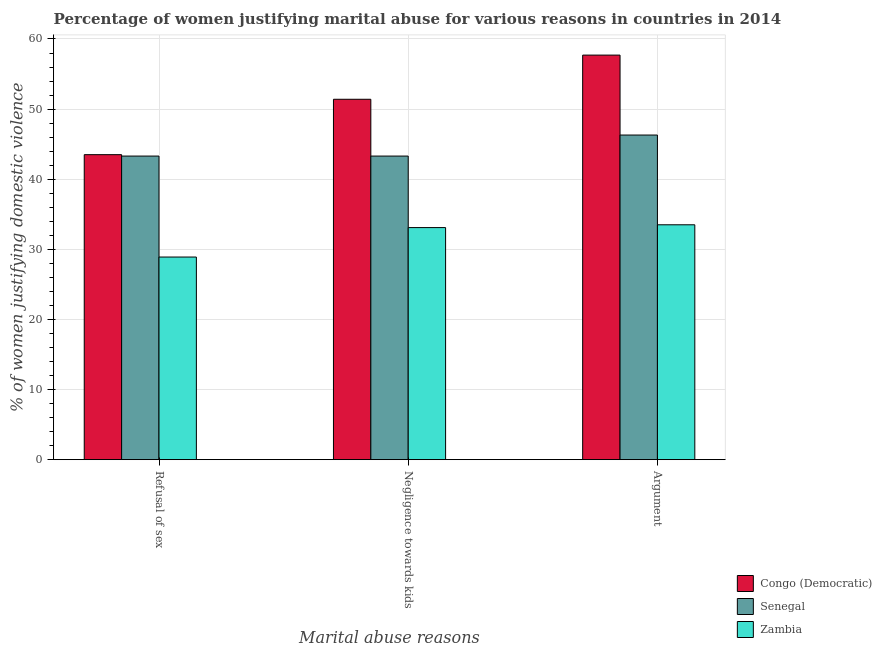How many bars are there on the 2nd tick from the left?
Keep it short and to the point. 3. How many bars are there on the 1st tick from the right?
Keep it short and to the point. 3. What is the label of the 2nd group of bars from the left?
Your answer should be compact. Negligence towards kids. What is the percentage of women justifying domestic violence due to arguments in Zambia?
Offer a terse response. 33.5. Across all countries, what is the maximum percentage of women justifying domestic violence due to arguments?
Keep it short and to the point. 57.7. Across all countries, what is the minimum percentage of women justifying domestic violence due to arguments?
Offer a terse response. 33.5. In which country was the percentage of women justifying domestic violence due to arguments maximum?
Your answer should be very brief. Congo (Democratic). In which country was the percentage of women justifying domestic violence due to negligence towards kids minimum?
Give a very brief answer. Zambia. What is the total percentage of women justifying domestic violence due to refusal of sex in the graph?
Your response must be concise. 115.7. What is the difference between the percentage of women justifying domestic violence due to refusal of sex in Senegal and that in Zambia?
Keep it short and to the point. 14.4. What is the difference between the percentage of women justifying domestic violence due to arguments in Senegal and the percentage of women justifying domestic violence due to negligence towards kids in Zambia?
Your answer should be very brief. 13.2. What is the average percentage of women justifying domestic violence due to negligence towards kids per country?
Make the answer very short. 42.6. In how many countries, is the percentage of women justifying domestic violence due to arguments greater than 20 %?
Your answer should be very brief. 3. What is the ratio of the percentage of women justifying domestic violence due to refusal of sex in Congo (Democratic) to that in Senegal?
Your response must be concise. 1. Is the percentage of women justifying domestic violence due to negligence towards kids in Congo (Democratic) less than that in Zambia?
Ensure brevity in your answer.  No. Is the difference between the percentage of women justifying domestic violence due to arguments in Zambia and Senegal greater than the difference between the percentage of women justifying domestic violence due to negligence towards kids in Zambia and Senegal?
Keep it short and to the point. No. What is the difference between the highest and the second highest percentage of women justifying domestic violence due to negligence towards kids?
Make the answer very short. 8.1. What is the difference between the highest and the lowest percentage of women justifying domestic violence due to refusal of sex?
Ensure brevity in your answer.  14.6. Is the sum of the percentage of women justifying domestic violence due to negligence towards kids in Zambia and Congo (Democratic) greater than the maximum percentage of women justifying domestic violence due to refusal of sex across all countries?
Your response must be concise. Yes. What does the 1st bar from the left in Argument represents?
Keep it short and to the point. Congo (Democratic). What does the 2nd bar from the right in Negligence towards kids represents?
Your response must be concise. Senegal. Is it the case that in every country, the sum of the percentage of women justifying domestic violence due to refusal of sex and percentage of women justifying domestic violence due to negligence towards kids is greater than the percentage of women justifying domestic violence due to arguments?
Ensure brevity in your answer.  Yes. Are all the bars in the graph horizontal?
Give a very brief answer. No. What is the difference between two consecutive major ticks on the Y-axis?
Offer a terse response. 10. Where does the legend appear in the graph?
Give a very brief answer. Bottom right. What is the title of the graph?
Your answer should be very brief. Percentage of women justifying marital abuse for various reasons in countries in 2014. Does "Tunisia" appear as one of the legend labels in the graph?
Provide a short and direct response. No. What is the label or title of the X-axis?
Offer a very short reply. Marital abuse reasons. What is the label or title of the Y-axis?
Your response must be concise. % of women justifying domestic violence. What is the % of women justifying domestic violence in Congo (Democratic) in Refusal of sex?
Keep it short and to the point. 43.5. What is the % of women justifying domestic violence in Senegal in Refusal of sex?
Make the answer very short. 43.3. What is the % of women justifying domestic violence of Zambia in Refusal of sex?
Make the answer very short. 28.9. What is the % of women justifying domestic violence in Congo (Democratic) in Negligence towards kids?
Provide a succinct answer. 51.4. What is the % of women justifying domestic violence of Senegal in Negligence towards kids?
Provide a succinct answer. 43.3. What is the % of women justifying domestic violence in Zambia in Negligence towards kids?
Your answer should be very brief. 33.1. What is the % of women justifying domestic violence of Congo (Democratic) in Argument?
Your answer should be compact. 57.7. What is the % of women justifying domestic violence in Senegal in Argument?
Ensure brevity in your answer.  46.3. What is the % of women justifying domestic violence of Zambia in Argument?
Give a very brief answer. 33.5. Across all Marital abuse reasons, what is the maximum % of women justifying domestic violence of Congo (Democratic)?
Provide a short and direct response. 57.7. Across all Marital abuse reasons, what is the maximum % of women justifying domestic violence of Senegal?
Offer a terse response. 46.3. Across all Marital abuse reasons, what is the maximum % of women justifying domestic violence in Zambia?
Keep it short and to the point. 33.5. Across all Marital abuse reasons, what is the minimum % of women justifying domestic violence in Congo (Democratic)?
Keep it short and to the point. 43.5. Across all Marital abuse reasons, what is the minimum % of women justifying domestic violence of Senegal?
Your answer should be compact. 43.3. Across all Marital abuse reasons, what is the minimum % of women justifying domestic violence of Zambia?
Offer a terse response. 28.9. What is the total % of women justifying domestic violence in Congo (Democratic) in the graph?
Offer a terse response. 152.6. What is the total % of women justifying domestic violence in Senegal in the graph?
Ensure brevity in your answer.  132.9. What is the total % of women justifying domestic violence in Zambia in the graph?
Make the answer very short. 95.5. What is the difference between the % of women justifying domestic violence in Congo (Democratic) in Refusal of sex and that in Negligence towards kids?
Ensure brevity in your answer.  -7.9. What is the difference between the % of women justifying domestic violence in Senegal in Refusal of sex and that in Negligence towards kids?
Keep it short and to the point. 0. What is the difference between the % of women justifying domestic violence of Congo (Democratic) in Refusal of sex and the % of women justifying domestic violence of Senegal in Negligence towards kids?
Your answer should be very brief. 0.2. What is the difference between the % of women justifying domestic violence in Senegal in Refusal of sex and the % of women justifying domestic violence in Zambia in Negligence towards kids?
Give a very brief answer. 10.2. What is the difference between the % of women justifying domestic violence of Senegal in Refusal of sex and the % of women justifying domestic violence of Zambia in Argument?
Ensure brevity in your answer.  9.8. What is the difference between the % of women justifying domestic violence of Senegal in Negligence towards kids and the % of women justifying domestic violence of Zambia in Argument?
Provide a short and direct response. 9.8. What is the average % of women justifying domestic violence in Congo (Democratic) per Marital abuse reasons?
Give a very brief answer. 50.87. What is the average % of women justifying domestic violence of Senegal per Marital abuse reasons?
Your answer should be compact. 44.3. What is the average % of women justifying domestic violence in Zambia per Marital abuse reasons?
Give a very brief answer. 31.83. What is the difference between the % of women justifying domestic violence of Congo (Democratic) and % of women justifying domestic violence of Senegal in Refusal of sex?
Your answer should be compact. 0.2. What is the difference between the % of women justifying domestic violence of Senegal and % of women justifying domestic violence of Zambia in Negligence towards kids?
Keep it short and to the point. 10.2. What is the difference between the % of women justifying domestic violence of Congo (Democratic) and % of women justifying domestic violence of Senegal in Argument?
Offer a terse response. 11.4. What is the difference between the % of women justifying domestic violence of Congo (Democratic) and % of women justifying domestic violence of Zambia in Argument?
Offer a very short reply. 24.2. What is the difference between the % of women justifying domestic violence of Senegal and % of women justifying domestic violence of Zambia in Argument?
Your response must be concise. 12.8. What is the ratio of the % of women justifying domestic violence in Congo (Democratic) in Refusal of sex to that in Negligence towards kids?
Provide a succinct answer. 0.85. What is the ratio of the % of women justifying domestic violence of Senegal in Refusal of sex to that in Negligence towards kids?
Keep it short and to the point. 1. What is the ratio of the % of women justifying domestic violence of Zambia in Refusal of sex to that in Negligence towards kids?
Offer a very short reply. 0.87. What is the ratio of the % of women justifying domestic violence of Congo (Democratic) in Refusal of sex to that in Argument?
Provide a succinct answer. 0.75. What is the ratio of the % of women justifying domestic violence of Senegal in Refusal of sex to that in Argument?
Keep it short and to the point. 0.94. What is the ratio of the % of women justifying domestic violence in Zambia in Refusal of sex to that in Argument?
Give a very brief answer. 0.86. What is the ratio of the % of women justifying domestic violence in Congo (Democratic) in Negligence towards kids to that in Argument?
Give a very brief answer. 0.89. What is the ratio of the % of women justifying domestic violence in Senegal in Negligence towards kids to that in Argument?
Offer a very short reply. 0.94. What is the ratio of the % of women justifying domestic violence in Zambia in Negligence towards kids to that in Argument?
Offer a very short reply. 0.99. What is the difference between the highest and the second highest % of women justifying domestic violence of Senegal?
Give a very brief answer. 3. What is the difference between the highest and the second highest % of women justifying domestic violence of Zambia?
Offer a very short reply. 0.4. 